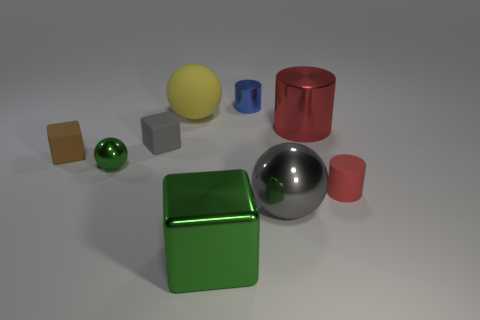There is a large yellow thing; what shape is it?
Offer a terse response. Sphere. Does the large green thing have the same material as the gray cube?
Your answer should be compact. No. Are there any green shiny blocks that are on the left side of the big ball that is behind the tiny red rubber cylinder that is to the right of the big gray metallic object?
Offer a terse response. No. What number of other things are there of the same shape as the big green object?
Your answer should be compact. 2. The big thing that is on the left side of the large gray metallic sphere and behind the green metallic block has what shape?
Provide a succinct answer. Sphere. There is a large ball that is behind the cylinder in front of the tiny brown matte block behind the green sphere; what color is it?
Provide a succinct answer. Yellow. Are there more large shiny cylinders that are left of the tiny shiny sphere than matte balls to the right of the tiny red object?
Your answer should be very brief. No. How many other objects are there of the same size as the red metal cylinder?
Your response must be concise. 3. There is a ball that is the same color as the large block; what is its size?
Provide a short and direct response. Small. What material is the big object behind the red cylinder behind the tiny green metal ball made of?
Keep it short and to the point. Rubber. 